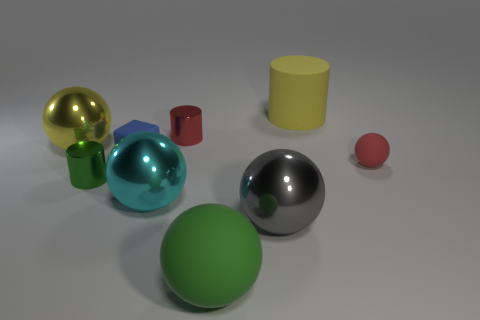Subtract all large gray spheres. How many spheres are left? 4 Add 1 big gray metal spheres. How many objects exist? 10 Subtract all yellow spheres. How many spheres are left? 4 Subtract 2 balls. How many balls are left? 3 Subtract all balls. How many objects are left? 4 Subtract all gray balls. Subtract all yellow cylinders. How many balls are left? 4 Subtract all brown balls. How many blue cylinders are left? 0 Subtract all tiny blue rubber cubes. Subtract all small red rubber spheres. How many objects are left? 7 Add 4 small red balls. How many small red balls are left? 5 Add 7 small blue things. How many small blue things exist? 8 